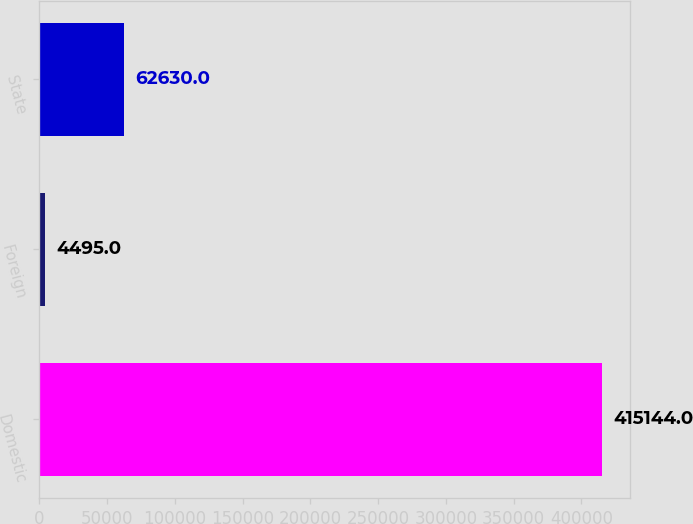Convert chart. <chart><loc_0><loc_0><loc_500><loc_500><bar_chart><fcel>Domestic<fcel>Foreign<fcel>State<nl><fcel>415144<fcel>4495<fcel>62630<nl></chart> 